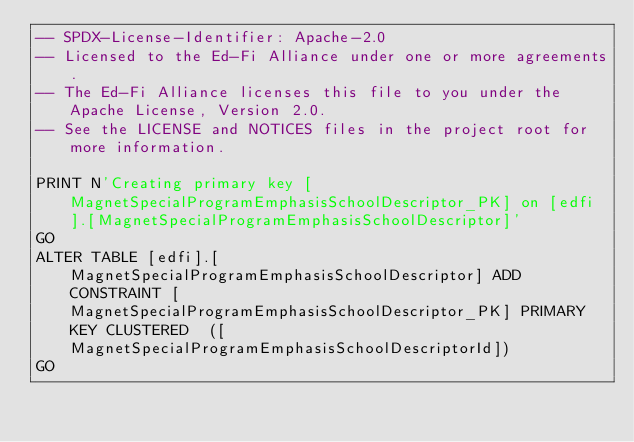Convert code to text. <code><loc_0><loc_0><loc_500><loc_500><_SQL_>-- SPDX-License-Identifier: Apache-2.0
-- Licensed to the Ed-Fi Alliance under one or more agreements.
-- The Ed-Fi Alliance licenses this file to you under the Apache License, Version 2.0.
-- See the LICENSE and NOTICES files in the project root for more information.

PRINT N'Creating primary key [MagnetSpecialProgramEmphasisSchoolDescriptor_PK] on [edfi].[MagnetSpecialProgramEmphasisSchoolDescriptor]'
GO
ALTER TABLE [edfi].[MagnetSpecialProgramEmphasisSchoolDescriptor] ADD CONSTRAINT [MagnetSpecialProgramEmphasisSchoolDescriptor_PK] PRIMARY KEY CLUSTERED  ([MagnetSpecialProgramEmphasisSchoolDescriptorId])
GO
</code> 